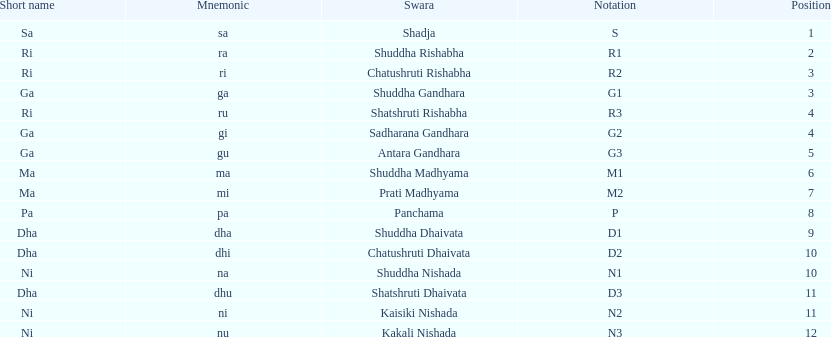After antara gandhara, which swara is next in sequence? Shuddha Madhyama. 